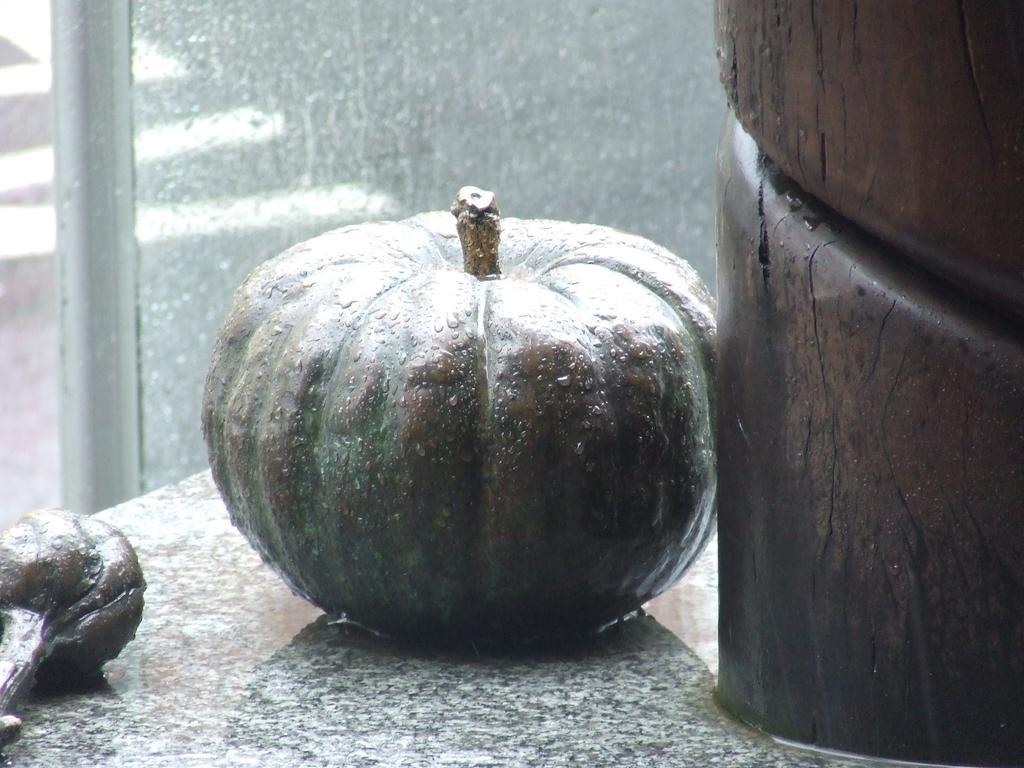Describe this image in one or two sentences. In the middle it is a pumpkin, at the back side it is a glass wall. 